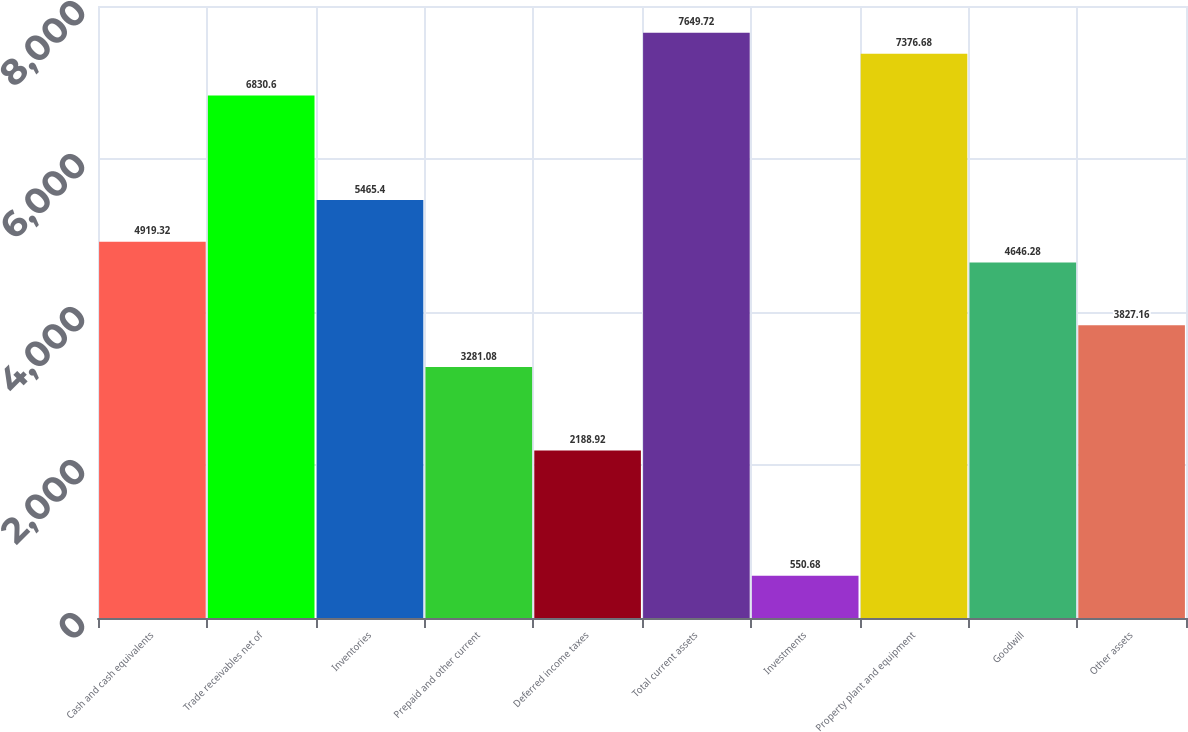<chart> <loc_0><loc_0><loc_500><loc_500><bar_chart><fcel>Cash and cash equivalents<fcel>Trade receivables net of<fcel>Inventories<fcel>Prepaid and other current<fcel>Deferred income taxes<fcel>Total current assets<fcel>Investments<fcel>Property plant and equipment<fcel>Goodwill<fcel>Other assets<nl><fcel>4919.32<fcel>6830.6<fcel>5465.4<fcel>3281.08<fcel>2188.92<fcel>7649.72<fcel>550.68<fcel>7376.68<fcel>4646.28<fcel>3827.16<nl></chart> 